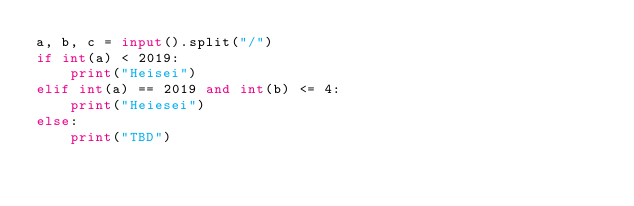Convert code to text. <code><loc_0><loc_0><loc_500><loc_500><_Python_>a, b, c = input().split("/")
if int(a) < 2019:
    print("Heisei")
elif int(a) == 2019 and int(b) <= 4:
    print("Heiesei")
else:
    print("TBD")</code> 